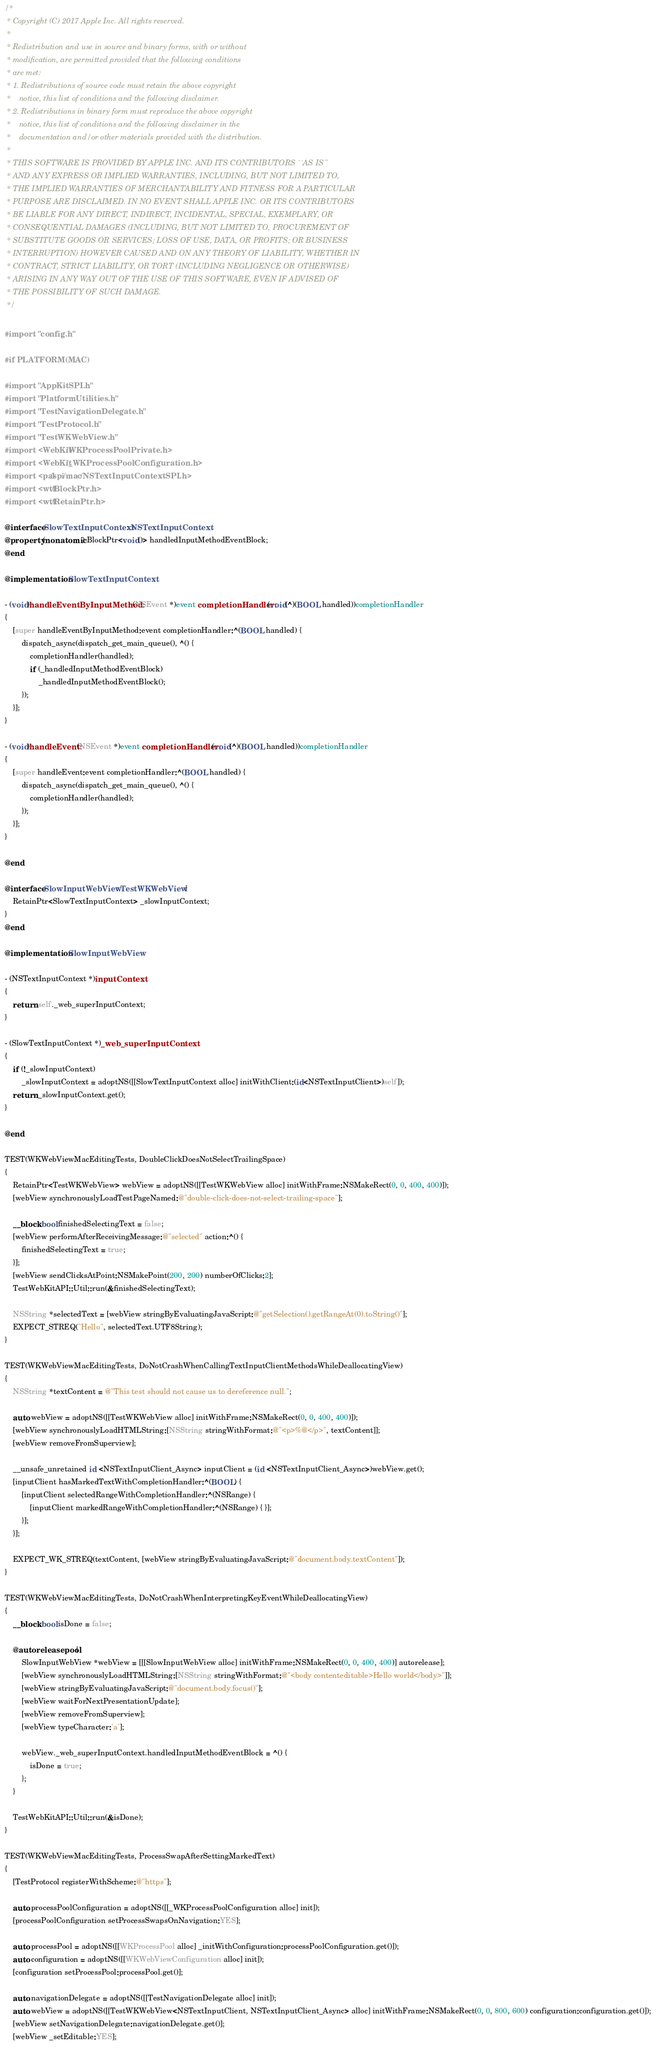Convert code to text. <code><loc_0><loc_0><loc_500><loc_500><_ObjectiveC_>/*
 * Copyright (C) 2017 Apple Inc. All rights reserved.
 *
 * Redistribution and use in source and binary forms, with or without
 * modification, are permitted provided that the following conditions
 * are met:
 * 1. Redistributions of source code must retain the above copyright
 *    notice, this list of conditions and the following disclaimer.
 * 2. Redistributions in binary form must reproduce the above copyright
 *    notice, this list of conditions and the following disclaimer in the
 *    documentation and/or other materials provided with the distribution.
 *
 * THIS SOFTWARE IS PROVIDED BY APPLE INC. AND ITS CONTRIBUTORS ``AS IS''
 * AND ANY EXPRESS OR IMPLIED WARRANTIES, INCLUDING, BUT NOT LIMITED TO,
 * THE IMPLIED WARRANTIES OF MERCHANTABILITY AND FITNESS FOR A PARTICULAR
 * PURPOSE ARE DISCLAIMED. IN NO EVENT SHALL APPLE INC. OR ITS CONTRIBUTORS
 * BE LIABLE FOR ANY DIRECT, INDIRECT, INCIDENTAL, SPECIAL, EXEMPLARY, OR
 * CONSEQUENTIAL DAMAGES (INCLUDING, BUT NOT LIMITED TO, PROCUREMENT OF
 * SUBSTITUTE GOODS OR SERVICES; LOSS OF USE, DATA, OR PROFITS; OR BUSINESS
 * INTERRUPTION) HOWEVER CAUSED AND ON ANY THEORY OF LIABILITY, WHETHER IN
 * CONTRACT, STRICT LIABILITY, OR TORT (INCLUDING NEGLIGENCE OR OTHERWISE)
 * ARISING IN ANY WAY OUT OF THE USE OF THIS SOFTWARE, EVEN IF ADVISED OF
 * THE POSSIBILITY OF SUCH DAMAGE.
 */

#import "config.h"

#if PLATFORM(MAC)

#import "AppKitSPI.h"
#import "PlatformUtilities.h"
#import "TestNavigationDelegate.h"
#import "TestProtocol.h"
#import "TestWKWebView.h"
#import <WebKit/WKProcessPoolPrivate.h>
#import <WebKit/_WKProcessPoolConfiguration.h>
#import <pal/spi/mac/NSTextInputContextSPI.h>
#import <wtf/BlockPtr.h>
#import <wtf/RetainPtr.h>

@interface SlowTextInputContext : NSTextInputContext
@property (nonatomic) BlockPtr<void()> handledInputMethodEventBlock;
@end

@implementation SlowTextInputContext

- (void)handleEventByInputMethod:(NSEvent *)event completionHandler:(void(^)(BOOL handled))completionHandler
{
    [super handleEventByInputMethod:event completionHandler:^(BOOL handled) {
        dispatch_async(dispatch_get_main_queue(), ^() {
            completionHandler(handled);
            if (_handledInputMethodEventBlock)
                _handledInputMethodEventBlock();
        });
    }];
}

- (void)handleEvent:(NSEvent *)event completionHandler:(void(^)(BOOL handled))completionHandler
{
    [super handleEvent:event completionHandler:^(BOOL handled) {
        dispatch_async(dispatch_get_main_queue(), ^() {
            completionHandler(handled);
        });
    }];
}

@end

@interface SlowInputWebView : TestWKWebView {
    RetainPtr<SlowTextInputContext> _slowInputContext;
}
@end

@implementation SlowInputWebView

- (NSTextInputContext *)inputContext
{
    return self._web_superInputContext;
}

- (SlowTextInputContext *)_web_superInputContext
{
    if (!_slowInputContext)
        _slowInputContext = adoptNS([[SlowTextInputContext alloc] initWithClient:(id<NSTextInputClient>)self]);
    return _slowInputContext.get();
}

@end

TEST(WKWebViewMacEditingTests, DoubleClickDoesNotSelectTrailingSpace)
{
    RetainPtr<TestWKWebView> webView = adoptNS([[TestWKWebView alloc] initWithFrame:NSMakeRect(0, 0, 400, 400)]);
    [webView synchronouslyLoadTestPageNamed:@"double-click-does-not-select-trailing-space"];

    __block bool finishedSelectingText = false;
    [webView performAfterReceivingMessage:@"selected" action:^() {
        finishedSelectingText = true;
    }];
    [webView sendClicksAtPoint:NSMakePoint(200, 200) numberOfClicks:2];
    TestWebKitAPI::Util::run(&finishedSelectingText);

    NSString *selectedText = [webView stringByEvaluatingJavaScript:@"getSelection().getRangeAt(0).toString()"];
    EXPECT_STREQ("Hello", selectedText.UTF8String);
}

TEST(WKWebViewMacEditingTests, DoNotCrashWhenCallingTextInputClientMethodsWhileDeallocatingView)
{
    NSString *textContent = @"This test should not cause us to dereference null.";

    auto webView = adoptNS([[TestWKWebView alloc] initWithFrame:NSMakeRect(0, 0, 400, 400)]);
    [webView synchronouslyLoadHTMLString:[NSString stringWithFormat:@"<p>%@</p>", textContent]];
    [webView removeFromSuperview];

    __unsafe_unretained id <NSTextInputClient_Async> inputClient = (id <NSTextInputClient_Async>)webView.get();
    [inputClient hasMarkedTextWithCompletionHandler:^(BOOL) {
        [inputClient selectedRangeWithCompletionHandler:^(NSRange) {
            [inputClient markedRangeWithCompletionHandler:^(NSRange) { }];
        }];
    }];

    EXPECT_WK_STREQ(textContent, [webView stringByEvaluatingJavaScript:@"document.body.textContent"]);
}

TEST(WKWebViewMacEditingTests, DoNotCrashWhenInterpretingKeyEventWhileDeallocatingView)
{
    __block bool isDone = false;

    @autoreleasepool {
        SlowInputWebView *webView = [[[SlowInputWebView alloc] initWithFrame:NSMakeRect(0, 0, 400, 400)] autorelease];
        [webView synchronouslyLoadHTMLString:[NSString stringWithFormat:@"<body contenteditable>Hello world</body>"]];
        [webView stringByEvaluatingJavaScript:@"document.body.focus()"];
        [webView waitForNextPresentationUpdate];
        [webView removeFromSuperview];
        [webView typeCharacter:'a'];

        webView._web_superInputContext.handledInputMethodEventBlock = ^() {
            isDone = true;
        };
    }

    TestWebKitAPI::Util::run(&isDone);
}

TEST(WKWebViewMacEditingTests, ProcessSwapAfterSettingMarkedText)
{
    [TestProtocol registerWithScheme:@"https"];

    auto processPoolConfiguration = adoptNS([[_WKProcessPoolConfiguration alloc] init]);
    [processPoolConfiguration setProcessSwapsOnNavigation:YES];

    auto processPool = adoptNS([[WKProcessPool alloc] _initWithConfiguration:processPoolConfiguration.get()]);
    auto configuration = adoptNS([[WKWebViewConfiguration alloc] init]);
    [configuration setProcessPool:processPool.get()];

    auto navigationDelegate = adoptNS([[TestNavigationDelegate alloc] init]);
    auto webView = adoptNS([[TestWKWebView<NSTextInputClient, NSTextInputClient_Async> alloc] initWithFrame:NSMakeRect(0, 0, 800, 600) configuration:configuration.get()]);
    [webView setNavigationDelegate:navigationDelegate.get()];
    [webView _setEditable:YES];
</code> 